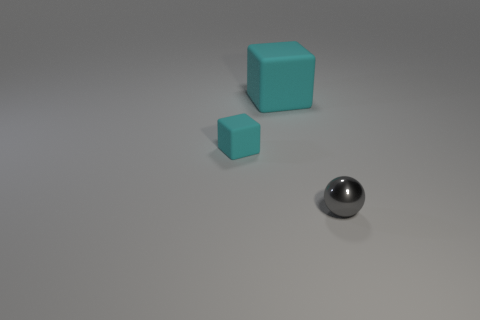Add 2 blue shiny cubes. How many objects exist? 5 Subtract 1 balls. How many balls are left? 0 Subtract all spheres. How many objects are left? 2 Subtract all cyan spheres. Subtract all red cubes. How many spheres are left? 1 Subtract all large objects. Subtract all cyan objects. How many objects are left? 0 Add 2 big cyan blocks. How many big cyan blocks are left? 3 Add 2 small gray shiny objects. How many small gray shiny objects exist? 3 Subtract 0 cyan spheres. How many objects are left? 3 